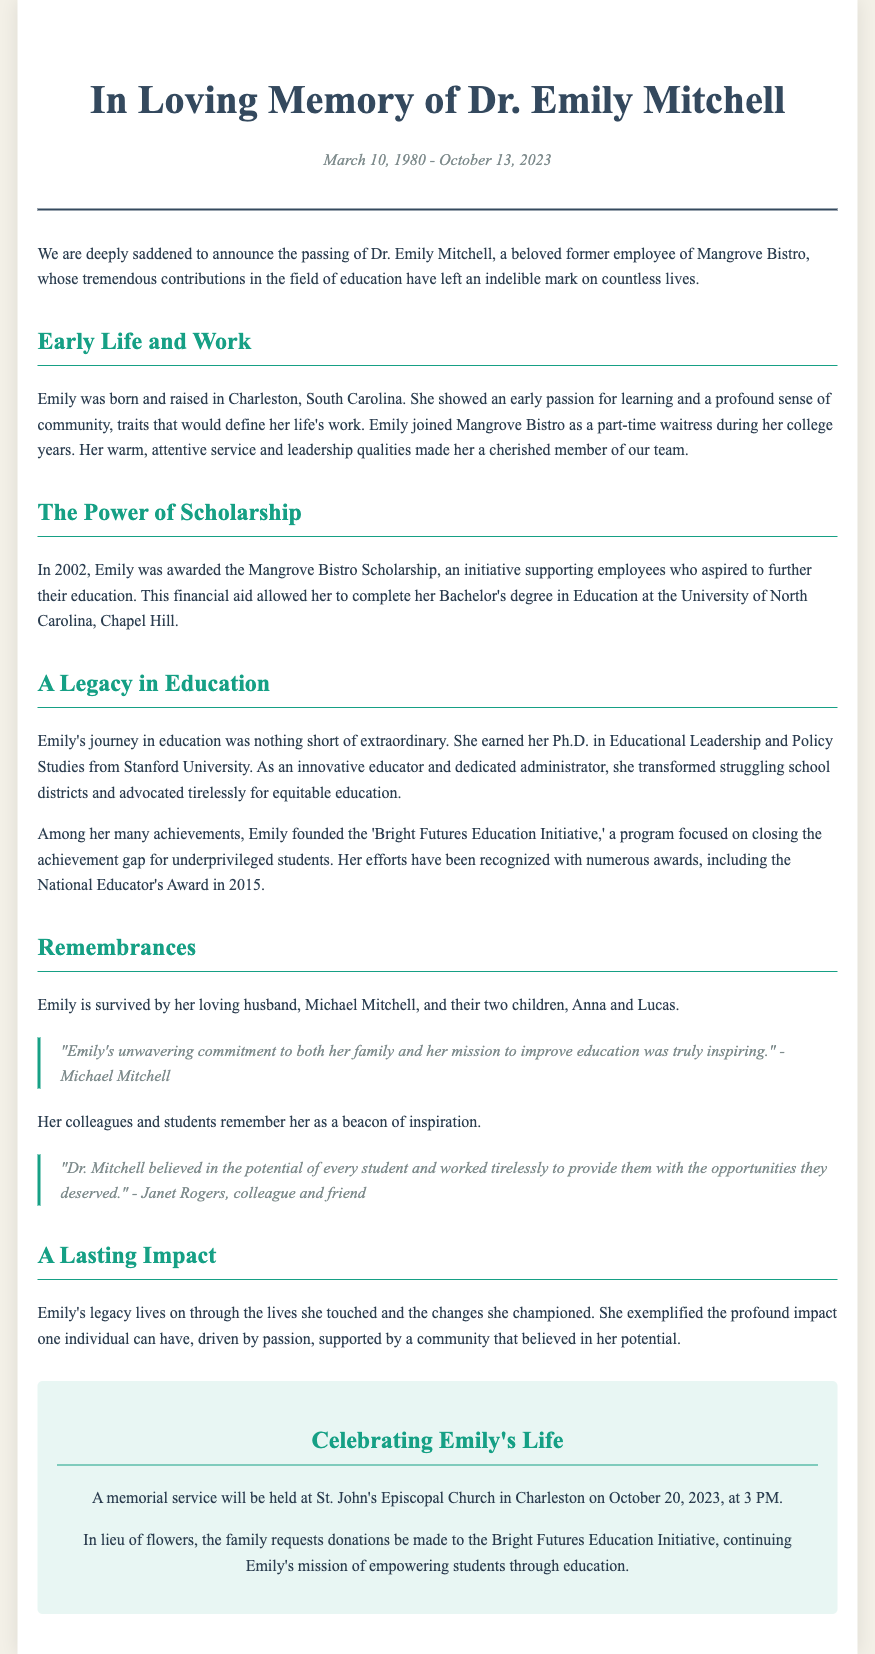What is the full name of the deceased? The document states that the full name of the deceased is Dr. Emily Mitchell.
Answer: Dr. Emily Mitchell When was Emily born? The document provides her birth date as March 10, 1980.
Answer: March 10, 1980 What scholarship did Emily receive? According to the document, she received the Mangrove Bistro Scholarship.
Answer: Mangrove Bistro Scholarship Which university did Emily attend for her Bachelor's degree? The document mentions that she completed her degree at the University of North Carolina, Chapel Hill.
Answer: University of North Carolina, Chapel Hill What initiative did Emily found? The document states that she founded the 'Bright Futures Education Initiative.'
Answer: Bright Futures Education Initiative What was Emily's profession? The document describes her as an innovative educator and dedicated administrator.
Answer: Educator and administrator How many children did Emily have? The document states she had two children.
Answer: Two children What date is Emily's memorial service scheduled for? The document specifies that the memorial service will be held on October 20, 2023.
Answer: October 20, 2023 What type of donations are requested in lieu of flowers? The document requests donations to be made to the Bright Futures Education Initiative.
Answer: Bright Futures Education Initiative 